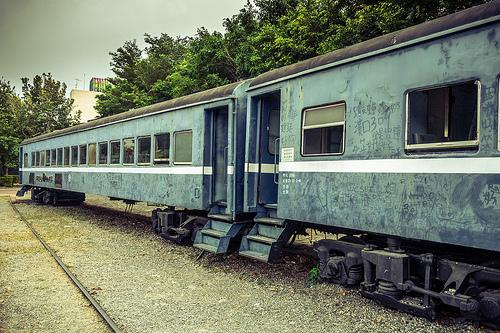What color are the trains and what is a distinguishing feature on them? The trains are blue with a white stripe painted on the side. Mention any visible numbers on the train and their significance. Number 304 is written on the train, possibly indicating the train's identification number. What unique pattern or design is present on the exterior of the train? Graffiti and stenciled letters and numbers can be seen on the train's exterior. How does the train's roof appear, and what is its color? The train has a black metal roof, which appears to be old and worn. Create a short narrative about the condition and location of the train. An old blue train with graffiti on its side is parked on tracks surrounded by trees, with buildings in the background. Identify the entry point and any additional features helping passengers board the train. There is an open doorway with steps leading into the train, and a handle at the doorway. Enumerate the elements related to the train's location and environment. Train tracks, green trees, old train cars, gravel underneath the train, and tall buildings in the background. What can be observed about the train's windows? The train has a row of windows on its side, with some having half-drawn shutters and others being open. Describe the immediate area under the train. A metal rail is buried in the ground, with gravel and weeds growing beside the train. List the types of vegetation seen near the train. Green trees along the tracks and weeds growing under the train. What event is likely happening in the image with the train? The train is parked or stopped at a station Compose a sentence that describes the overall scene with the train, buildings, and trees in the background. An old blue train with graffiti on the side is parked along the tracks, with green trees and tall buildings in the background. Determine whether the following objects are present in the image: a) a black metal roof, b) weeds growing under the train, c) tall buildings in the background. a) Yes, b) Yes, c) Yes Write a caption for the image that focuses on the train's attributes. An old blue train with a white stripe, open windows and doors, and graffiti on its side. Notice how the train's number is written as 403 instead of 304. The image mentions "number 304 written on the train." This instruction gives the wrong train number. Could those steps leading into the train be actually narrowing upwards? The image contains "steps leading into the train," but there is no mention of their shape or design. Introducing a specific design like "narrowing upwards" may confuse the viewer. It appears that the train cars are orange, not blue. The image describes the objects as "a few blue trains" and "an old blue train." This statement contradicts the train cars' color, creating confusion. Identify any text or numbers that appear in the image. Number 304 and stenciled letters and numbers on the side of the train How many open doorways are there in the train cars in the image? Two open doorways There are no trees in the background, right? The image contains objects like "green trees along the tracks" and "green trees behind the trains," suggesting that trees are present. This statement provides contradictory information. Are there any visible steps leading into the train? (Yes/No) Yes What color are the steps leading to the train? Blue What do you think of the pink stripe on the side of the train? No, it's not mentioned in the image. Explain the layout of the train's undercarriage, if visible. Machinery on the train's undercarriage is visible. Isn't the train's roof actually made of wood instead of metal? The object is described as "a black metal roof." This statement contradicts this information by proposing that the roof is made of wood, creating confusion. The train tracks seem to be floating in the air, aren't they? The image does not mention the train tracks being in the air, and it would be unusual to have train tracks floating. This statement introduces misleading information. Choose the correct option: How many train cars are in the image? a) one, b) two, c) three b) two Identify the type of material found in the ground near the train tracks. Gravel Provide a brief description of the blue train cars. Old blue train cars with white stripes, open windows, and graffiti on the sides. Considering the elements in the image, are the train cars old or new? Old train cars Is it possible that the train is completely devoid of graffiti? The image has multiple instances of graffiti like "graffiti of train side" and "graffiti on the train car." This statement contradicts the presence of graffiti in the image. Describe the positioning of the trees relative to the train. Green trees are behind the train, along the tracks. What is painted on the side of the train? Graffiti Write a short narrative describing the image. An old, weathered blue train sits along a track. Its doors and windows are open, and graffiti adorns its side. Behind the train, green trees and tall buildings can be seen in the distance. In the image, predict the type of activity that may take place around the train. Passengers boarding or alighting from the train 